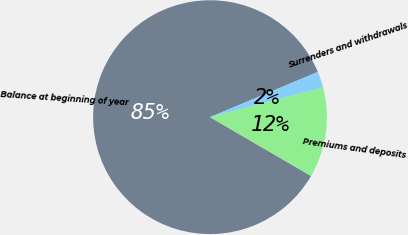<chart> <loc_0><loc_0><loc_500><loc_500><pie_chart><fcel>Balance at beginning of year<fcel>Premiums and deposits<fcel>Surrenders and withdrawals<nl><fcel>85.29%<fcel>12.49%<fcel>2.22%<nl></chart> 